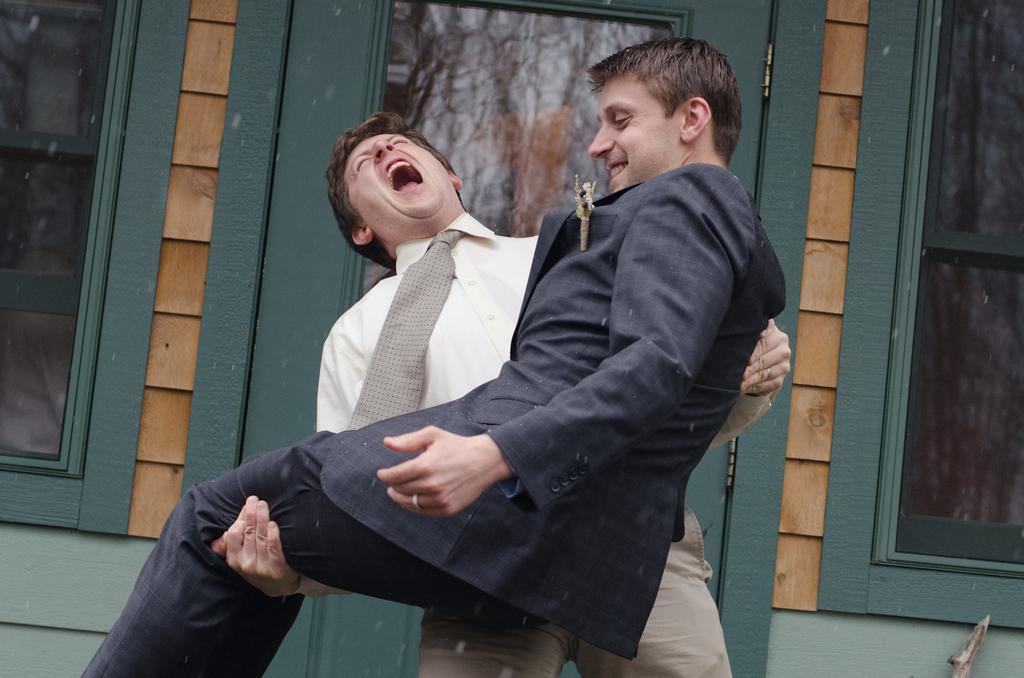Can you describe this image briefly? In this image there is a man lifting another man, in the background there is a house. 